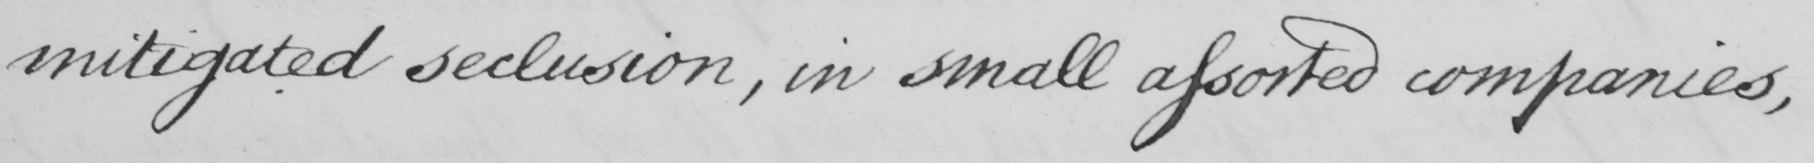Can you tell me what this handwritten text says? mitigated seclusion, in small assorted companies, 